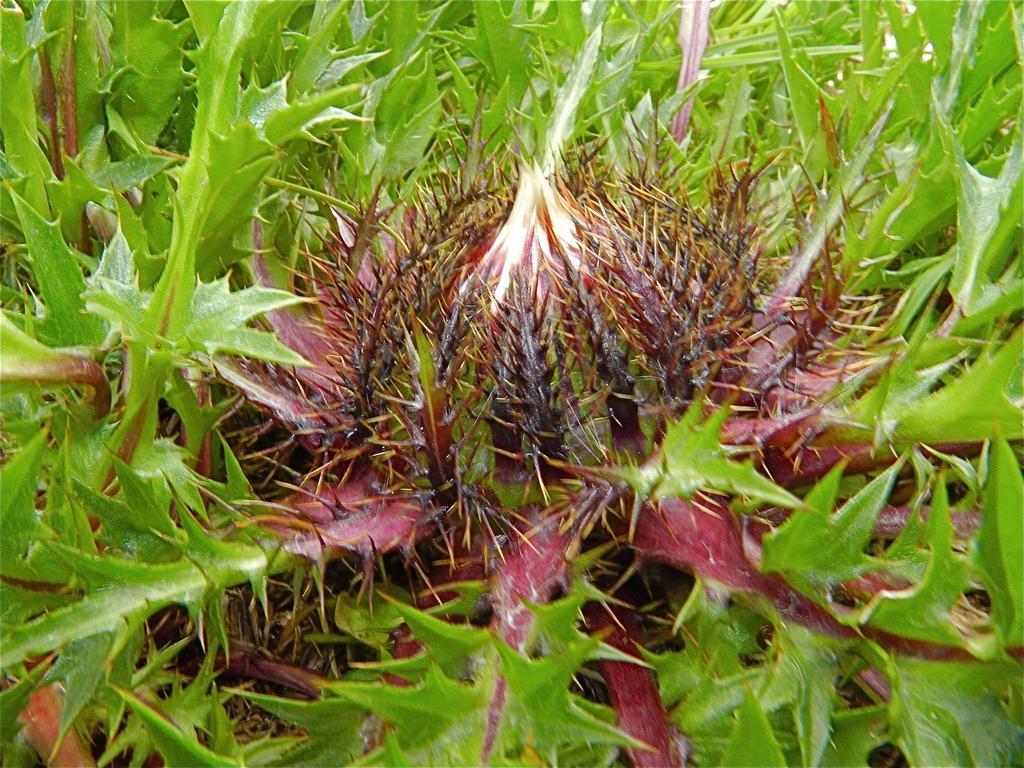Describe this image in one or two sentences. In this picture we can see some plants, there are some spikes of the plants here. 